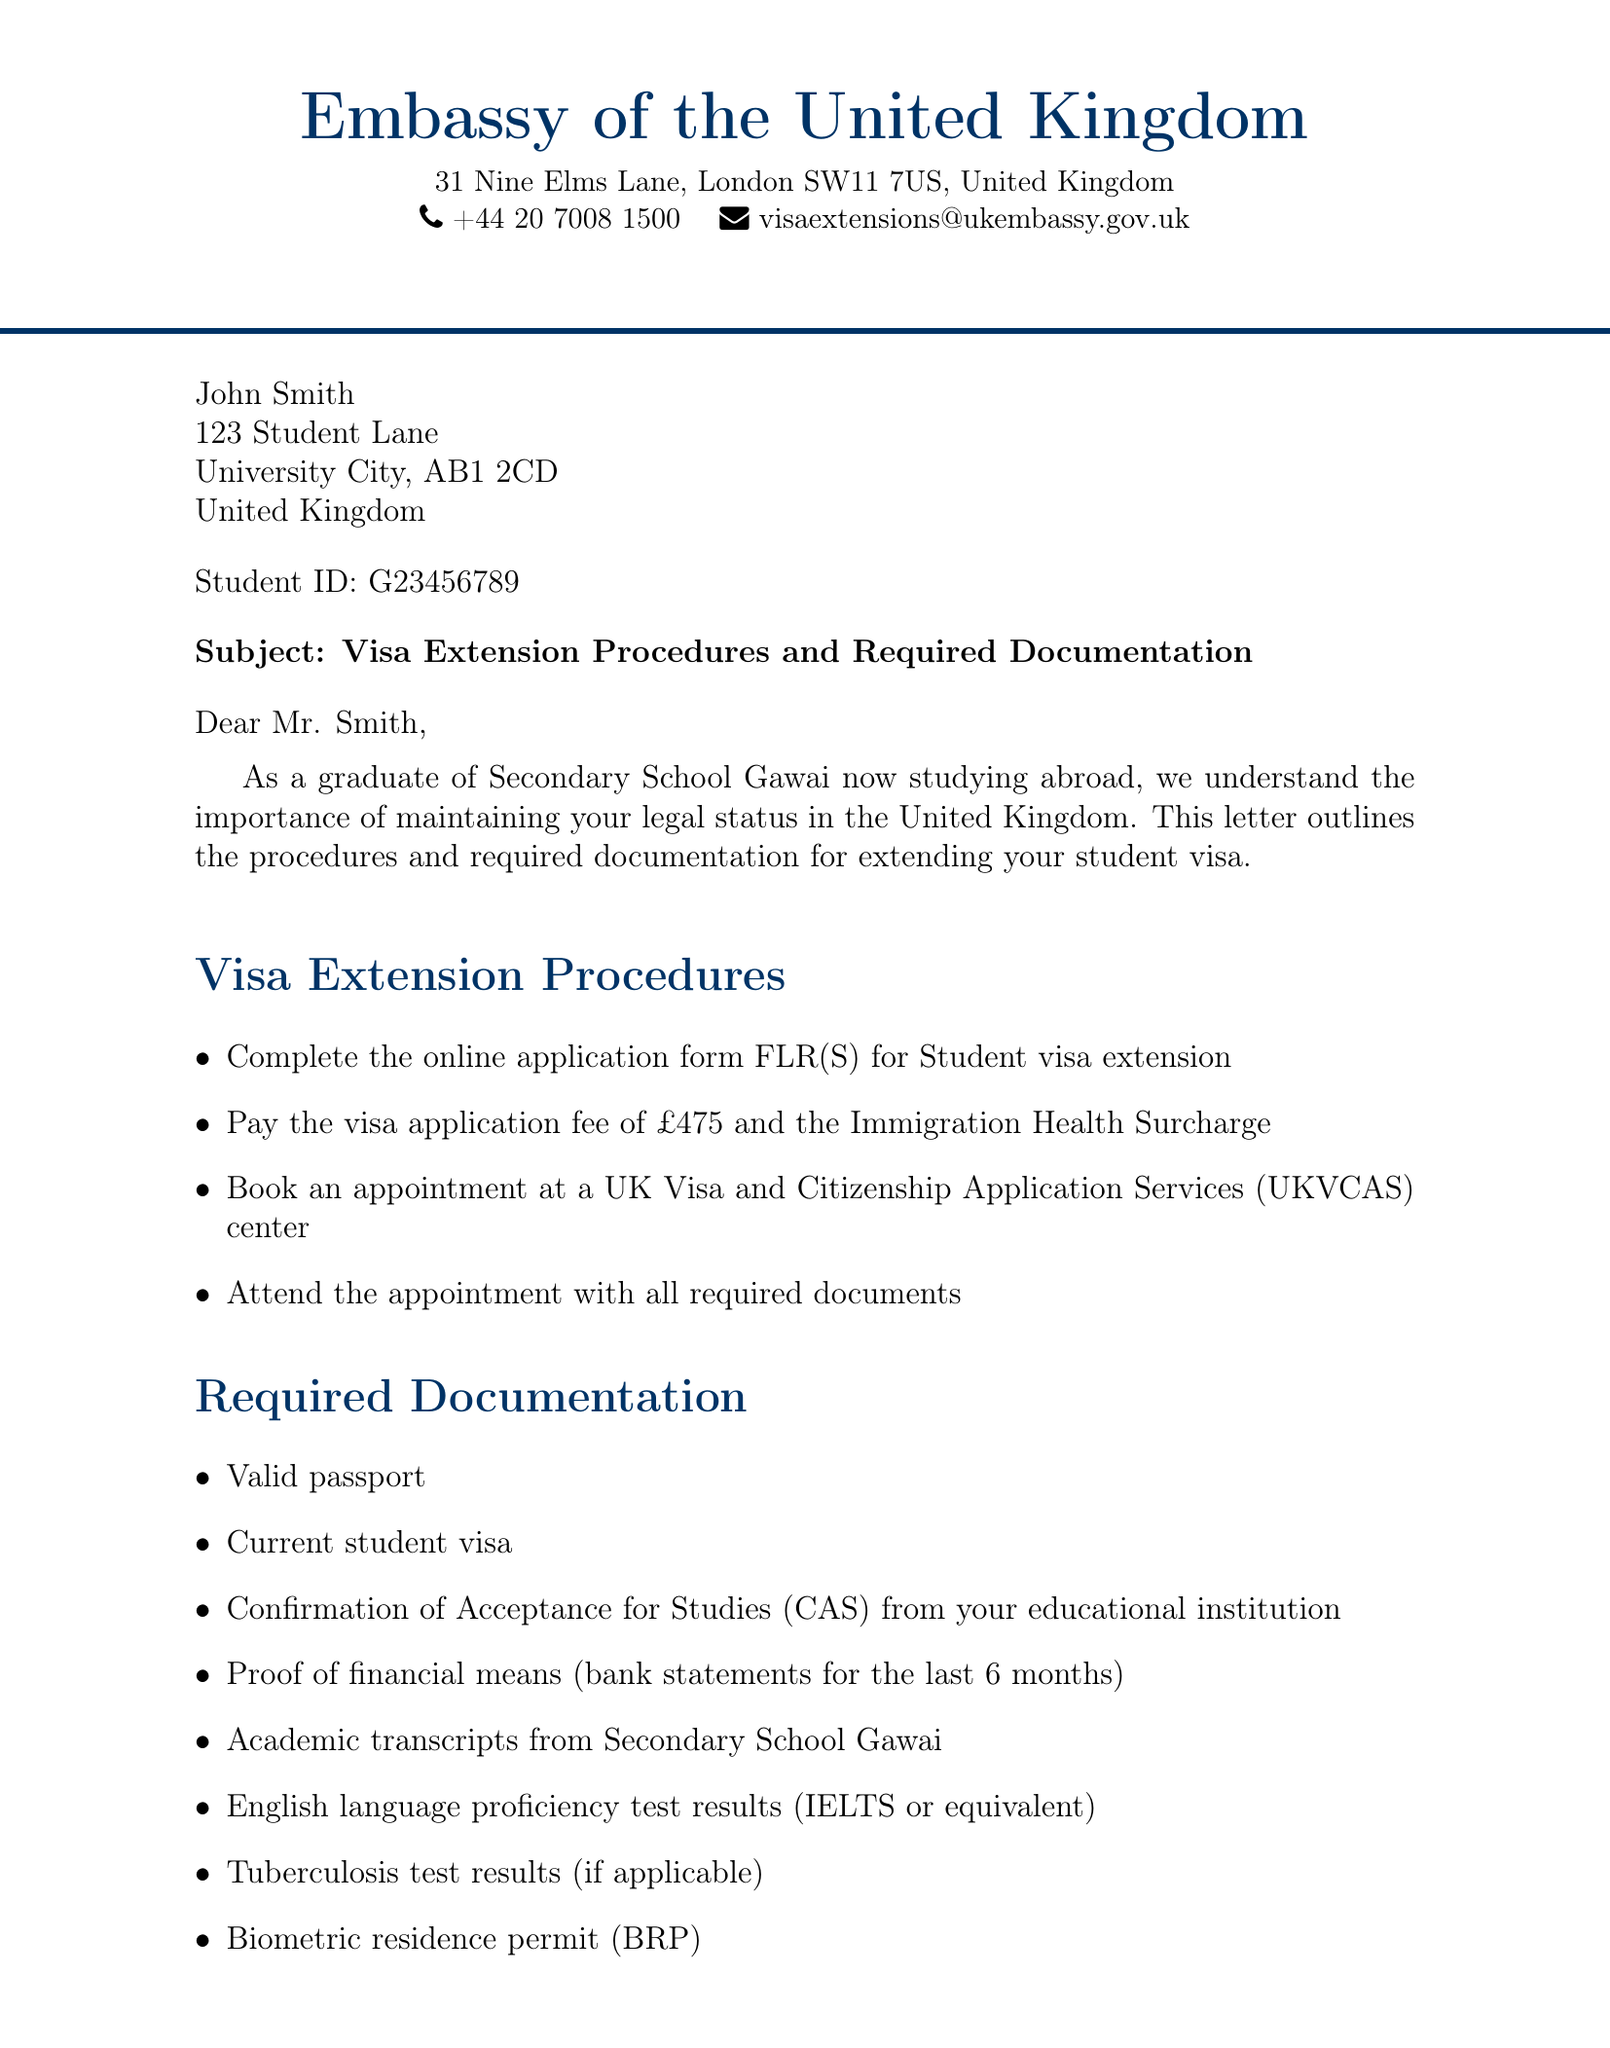What is the name of the embassy? The name of the embassy is clearly stated at the beginning of the document.
Answer: Embassy of the United Kingdom What is the visa application fee? The document specifies the fee that needs to be paid for the visa application.
Answer: £475 Who should be contacted for further assistance? The letter mentions the contact person at the embassy for inquiries.
Answer: Mrs. Emma Thompson What is the standard processing time for the visa extension? The document provides information about the processing timeline for the application.
Answer: 8 weeks What type of test results are required if applicable? The document lists required documents, including specific test results.
Answer: Tuberculosis test results What is the priority service fee? The additional information section mentions the cost of the priority service.
Answer: £500 What is needed from the educational institution? The document lists documents required for the visa extension, including this one.
Answer: Confirmation of Acceptance for Studies (CAS) Where can students find free support? The document indicates a resource available for student assistance during this process.
Answer: University’s international student office What is the email address for visa extensions? The contact information section includes an email for visa inquiries.
Answer: visaextensions@ukembassy.gov.uk 